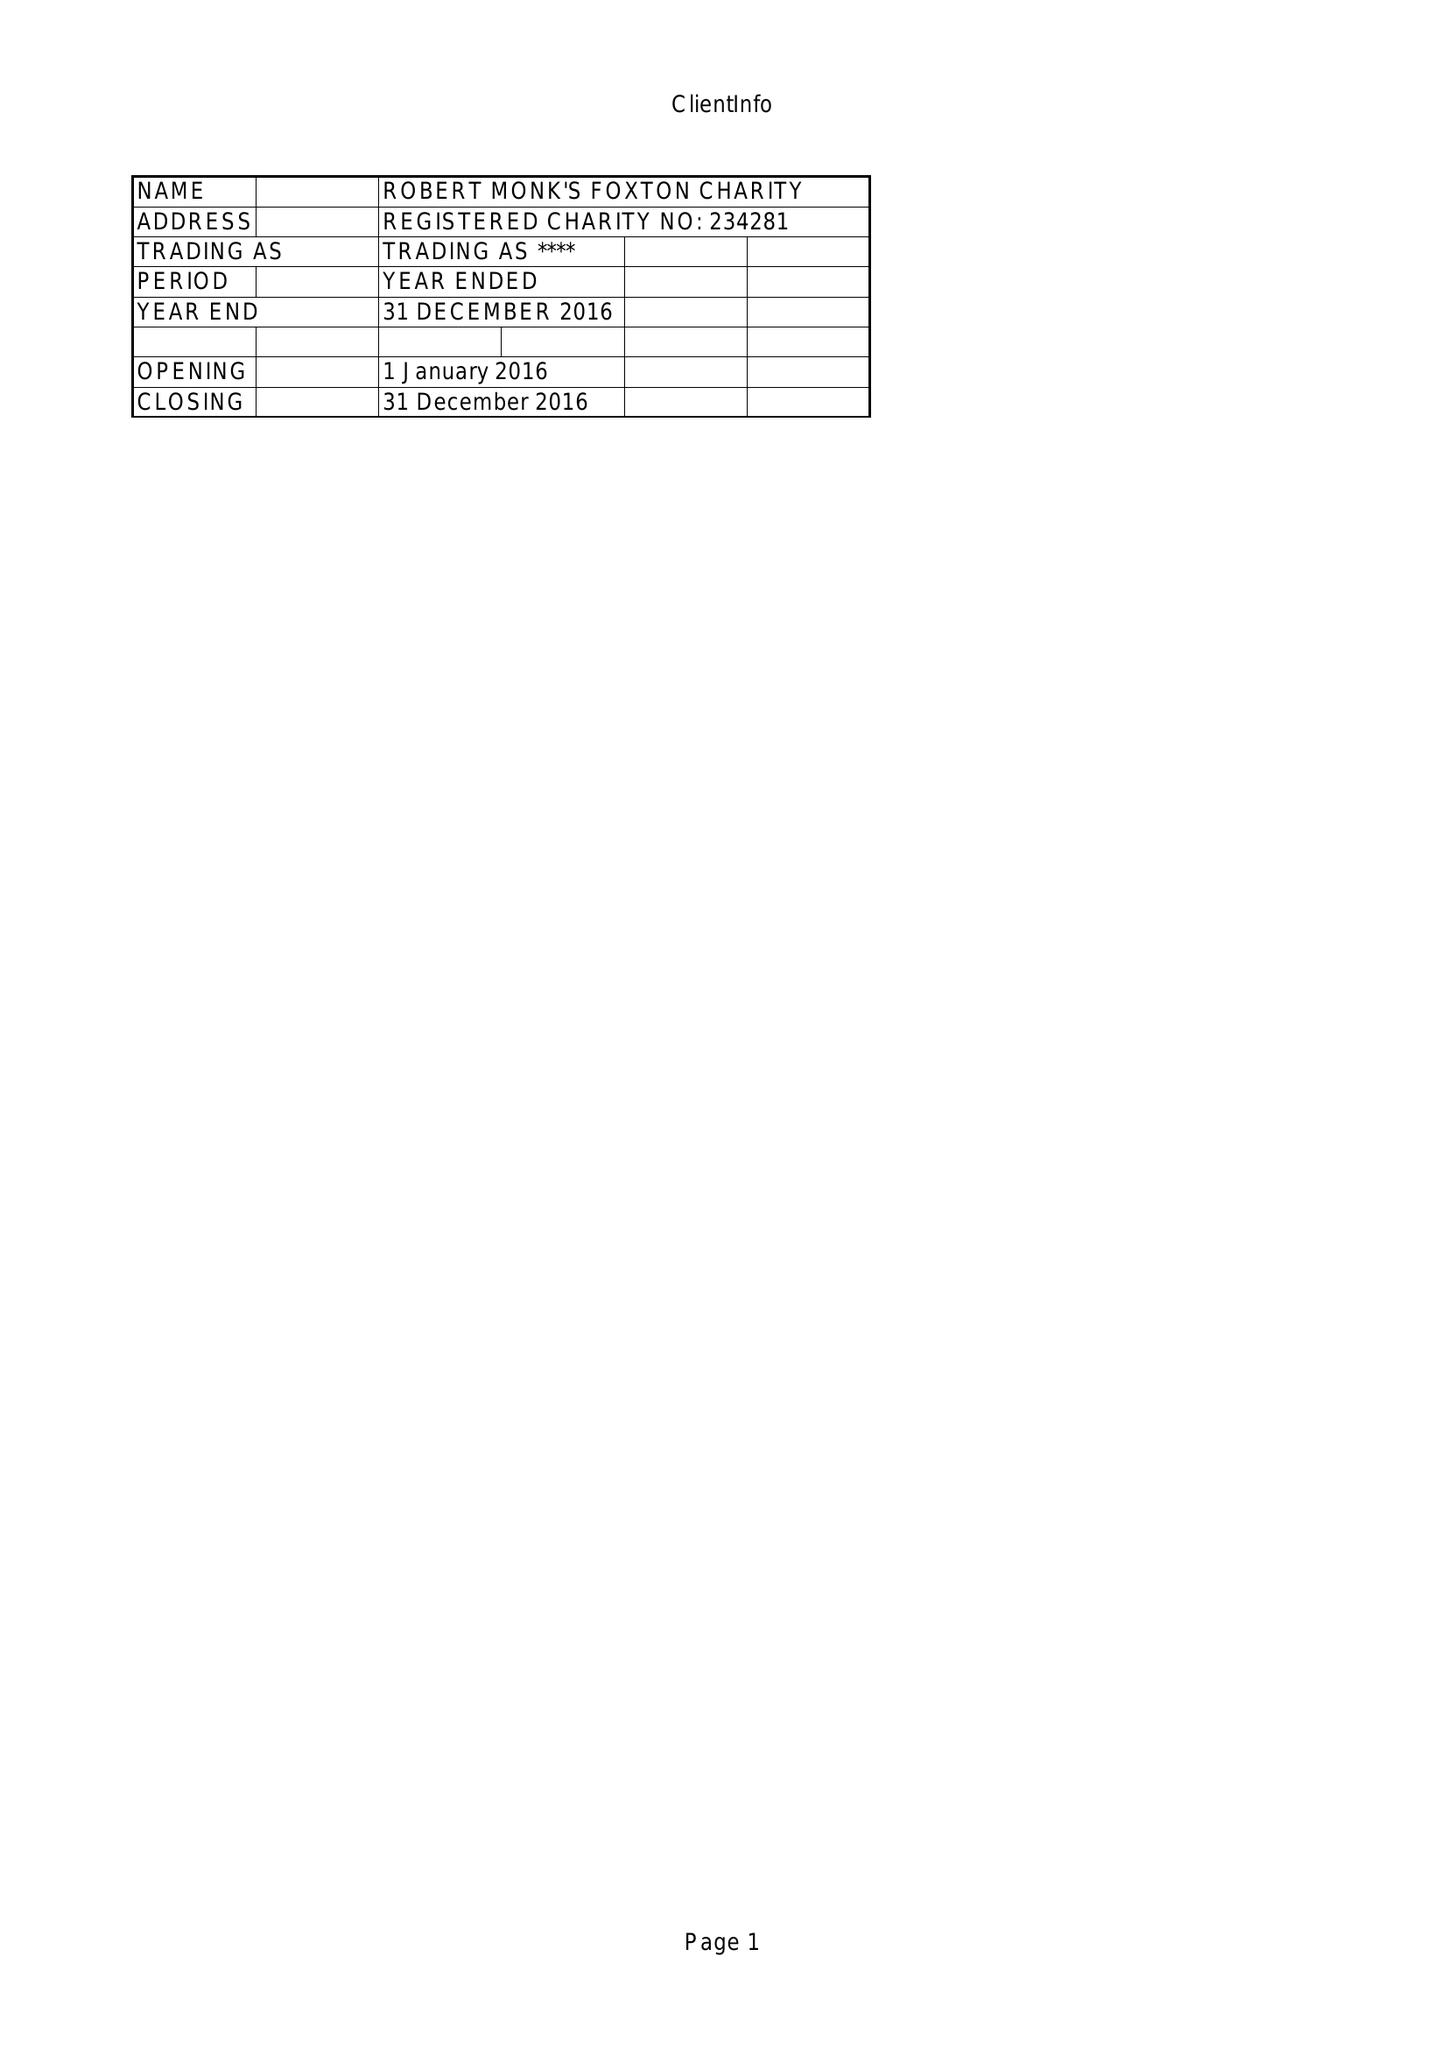What is the value for the report_date?
Answer the question using a single word or phrase. 2016-12-31 